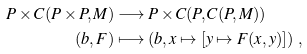Convert formula to latex. <formula><loc_0><loc_0><loc_500><loc_500>P \times C ( P \times P , M ) & \longrightarrow P \times C ( P , C ( P , M ) ) \\ ( b , F ) & \longmapsto ( b , x \mapsto [ y \mapsto F ( x , y ) ] ) \ ,</formula> 